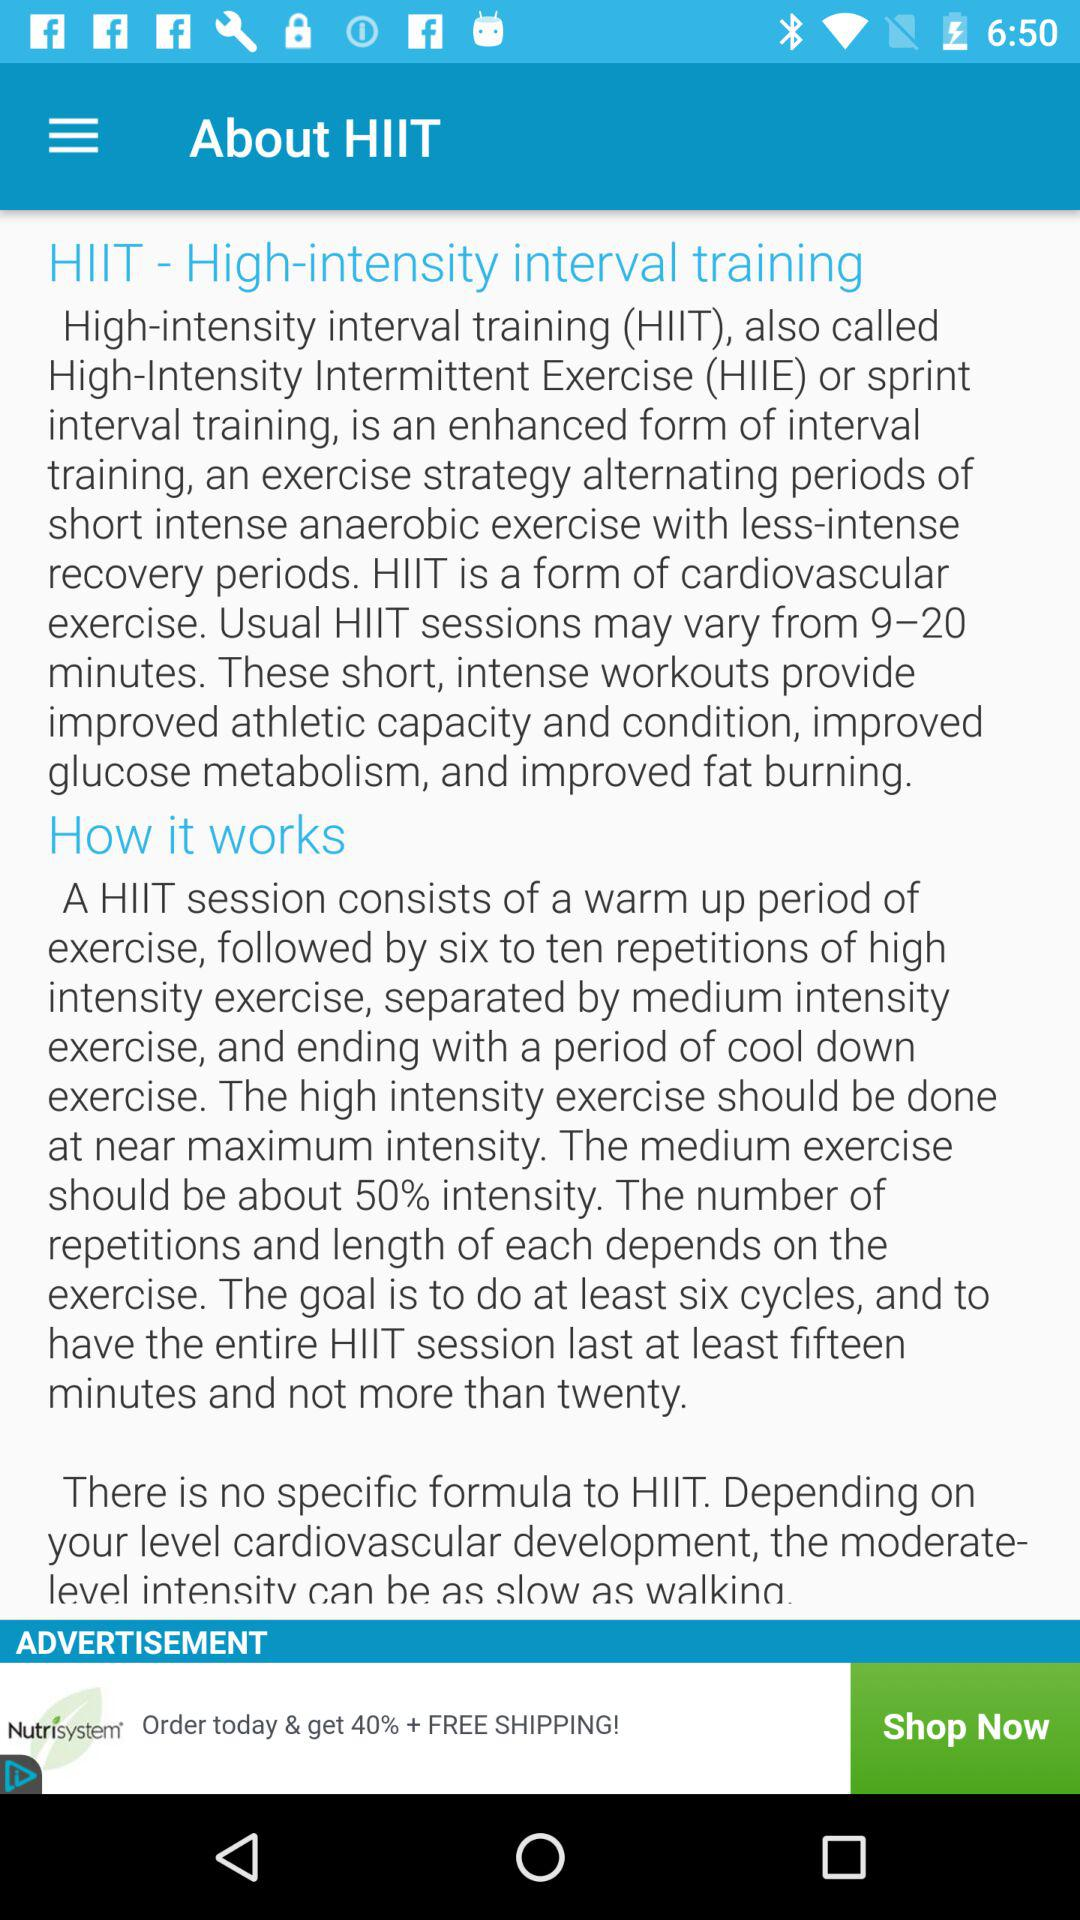What is the duration of HIIT sessions? The duration of HIIT sessions varies from 9 to 20 minutes. 